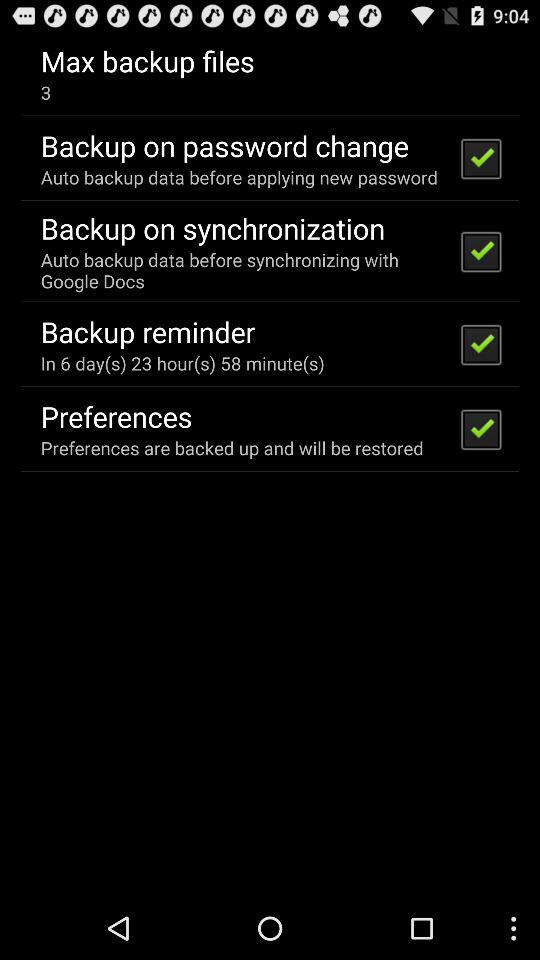What is the status of the "Preferences"? The status of the "Preferences" is "on". 